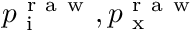Convert formula to latex. <formula><loc_0><loc_0><loc_500><loc_500>p _ { i } ^ { r a w } , p _ { x } ^ { r a w }</formula> 